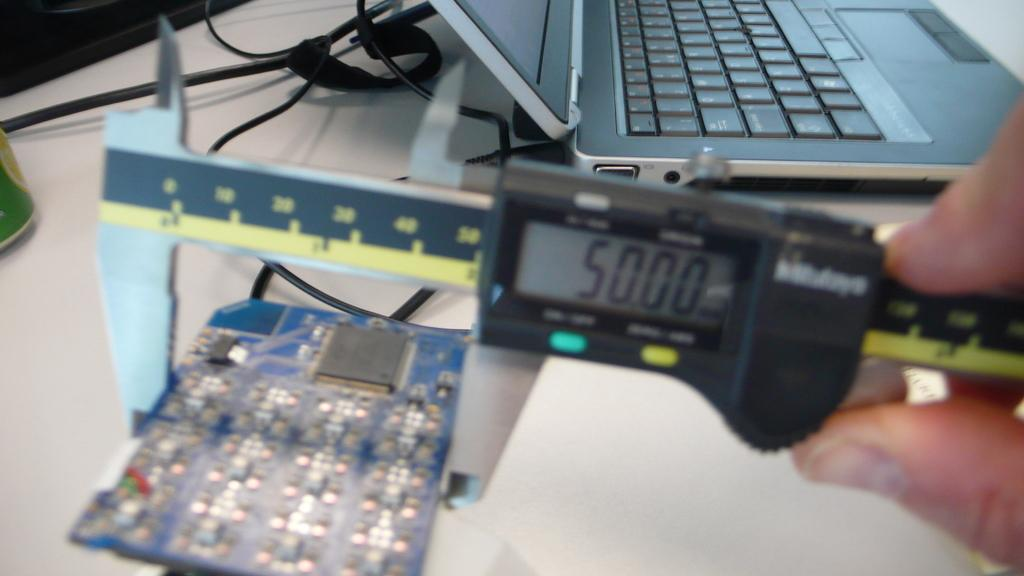Provide a one-sentence caption for the provided image. The readout on the electronic device says 5000. 